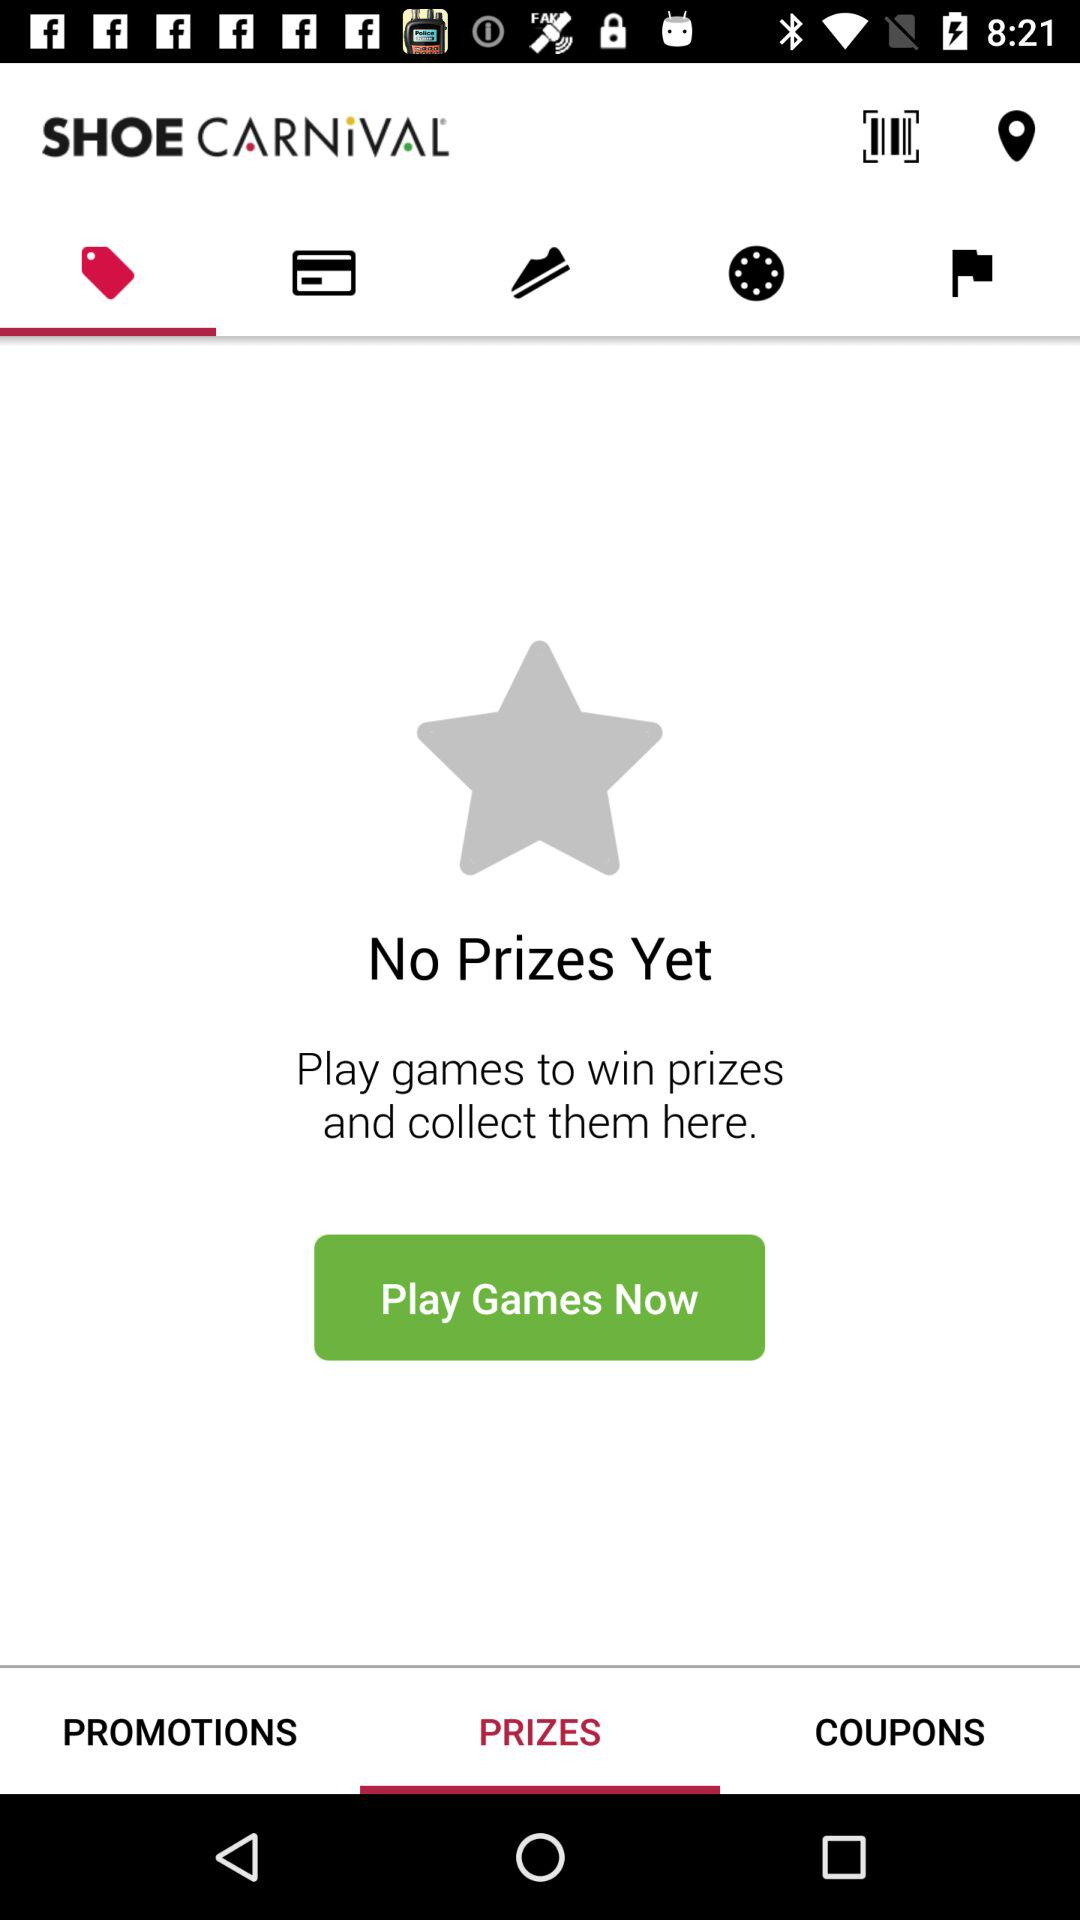What is the application name? The application name is "Shoe Carnival". 